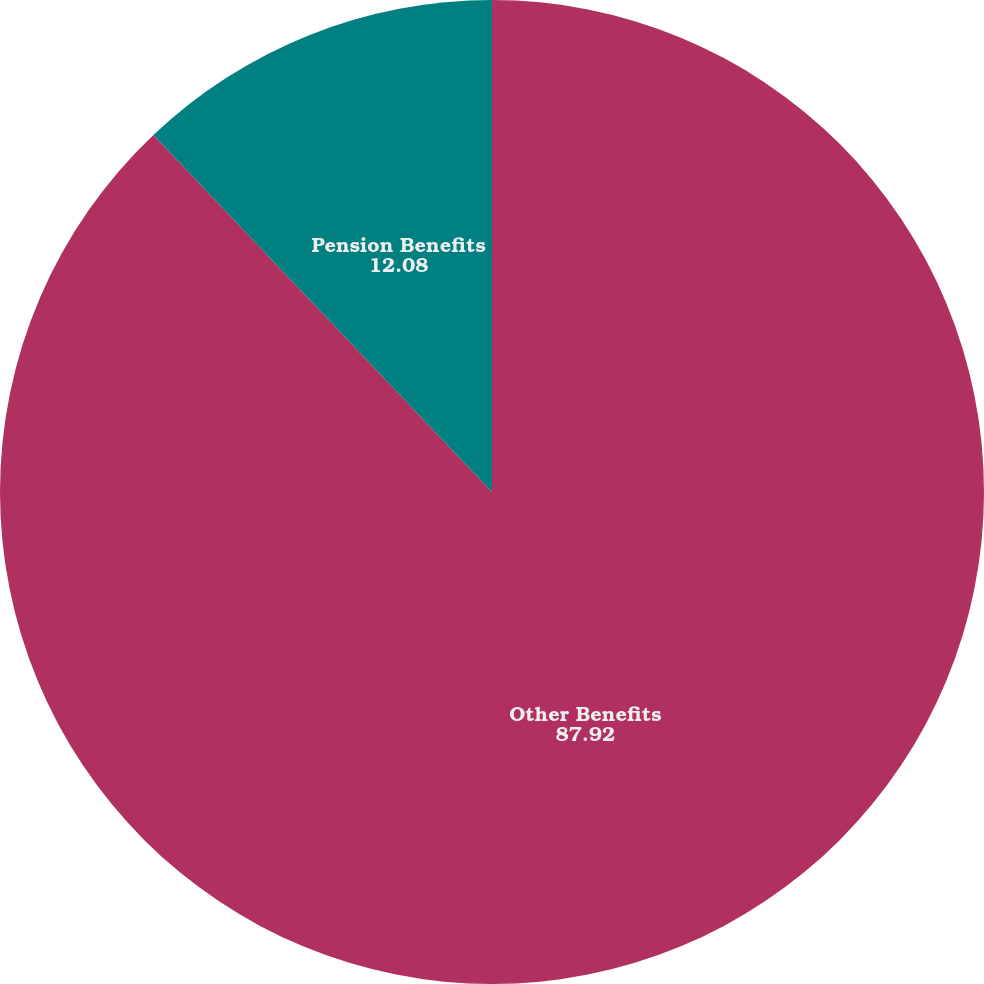<chart> <loc_0><loc_0><loc_500><loc_500><pie_chart><fcel>Other Benefits<fcel>Pension Benefits<nl><fcel>87.92%<fcel>12.08%<nl></chart> 